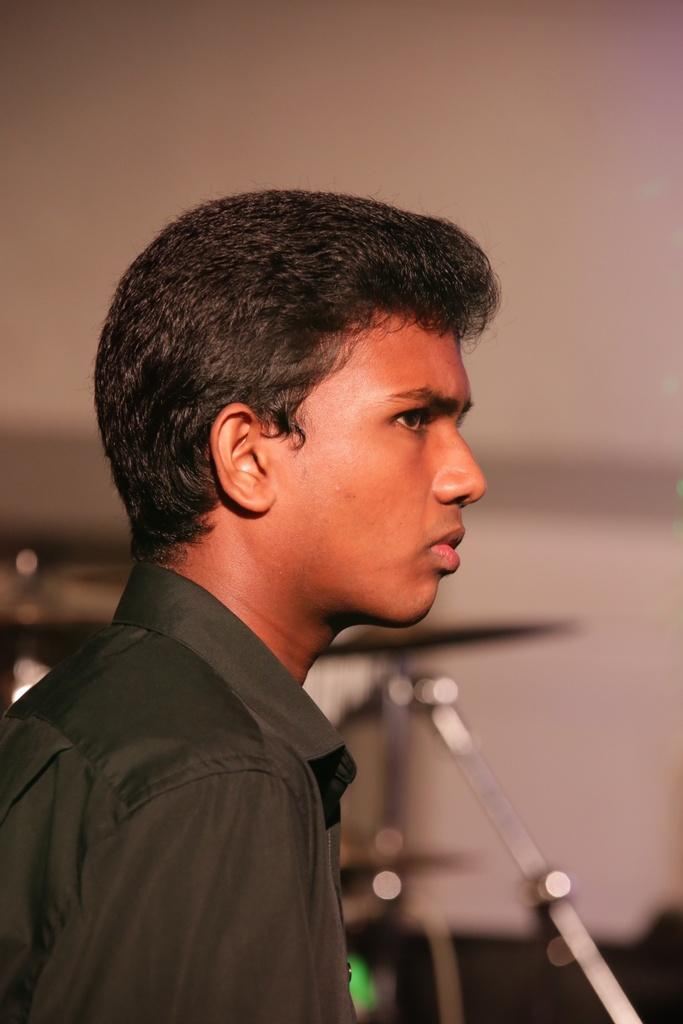Who is present in the image? There is a woman in the image. What is the woman wearing? The woman is wearing a black shirt. What can be seen in the background of the image? There is a partial view of an orchestra set in the image. What type of snake can be seen slithering across the page in the image? There is no snake or page present in the image; it features a woman wearing a black shirt and a partial view of an orchestra set. 